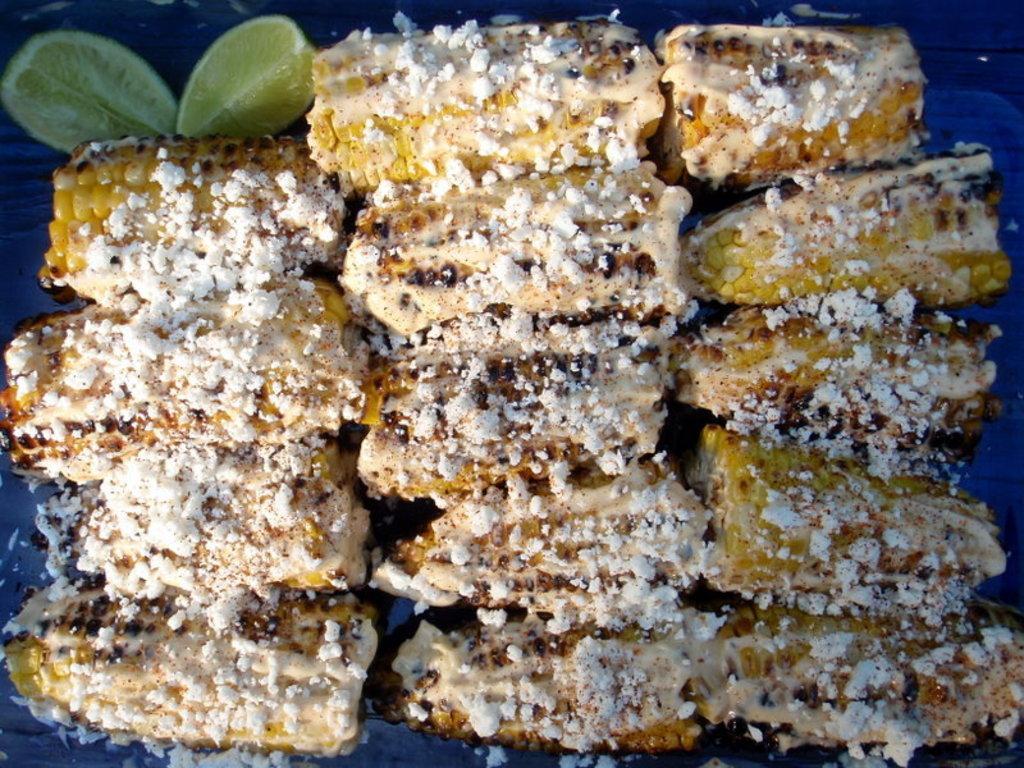Could you give a brief overview of what you see in this image? In this image I can see the food which is in white, cream and yellow color. To the side I can see two lemon slices and there is a blue background. 